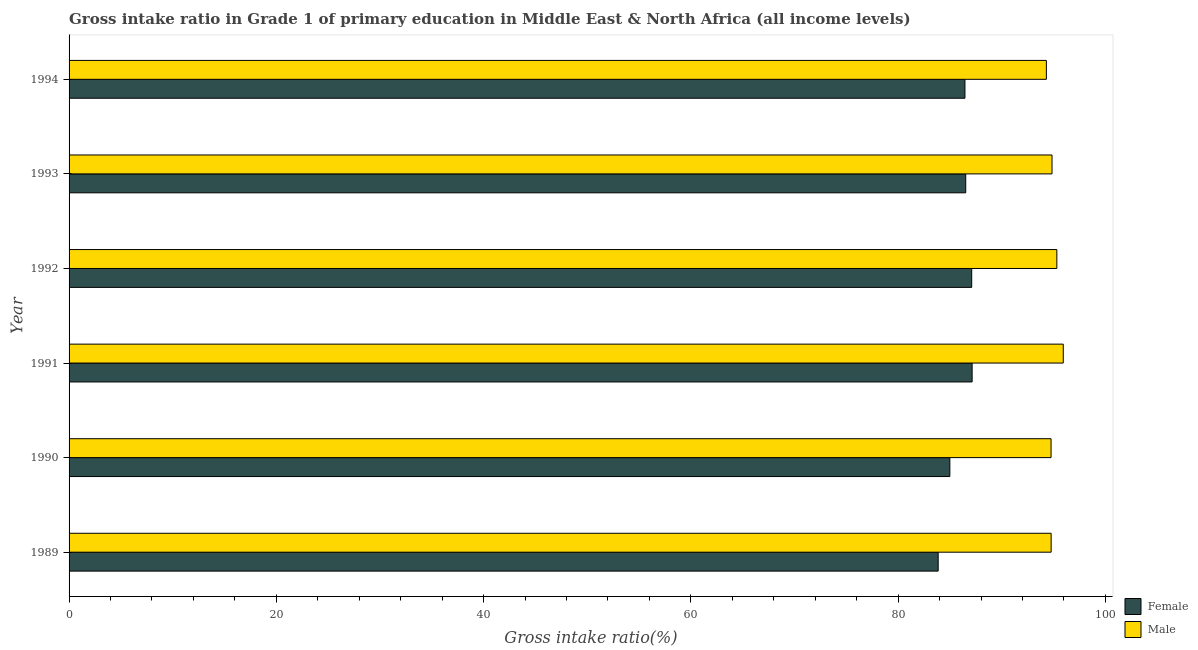How many groups of bars are there?
Provide a short and direct response. 6. In how many cases, is the number of bars for a given year not equal to the number of legend labels?
Ensure brevity in your answer.  0. What is the gross intake ratio(male) in 1990?
Give a very brief answer. 94.75. Across all years, what is the maximum gross intake ratio(male)?
Your answer should be very brief. 95.93. Across all years, what is the minimum gross intake ratio(male)?
Your answer should be compact. 94.3. In which year was the gross intake ratio(female) maximum?
Your answer should be compact. 1991. What is the total gross intake ratio(female) in the graph?
Ensure brevity in your answer.  516.04. What is the difference between the gross intake ratio(female) in 1991 and that in 1992?
Give a very brief answer. 0.04. What is the difference between the gross intake ratio(male) in 1991 and the gross intake ratio(female) in 1993?
Give a very brief answer. 9.41. What is the average gross intake ratio(male) per year?
Give a very brief answer. 94.98. In the year 1990, what is the difference between the gross intake ratio(female) and gross intake ratio(male)?
Offer a very short reply. -9.77. Is the gross intake ratio(male) in 1990 less than that in 1994?
Your answer should be compact. No. What is the difference between the highest and the second highest gross intake ratio(female)?
Give a very brief answer. 0.04. What is the difference between the highest and the lowest gross intake ratio(female)?
Offer a terse response. 3.28. Is the sum of the gross intake ratio(male) in 1989 and 1990 greater than the maximum gross intake ratio(female) across all years?
Give a very brief answer. Yes. How many bars are there?
Offer a terse response. 12. Are all the bars in the graph horizontal?
Ensure brevity in your answer.  Yes. Are the values on the major ticks of X-axis written in scientific E-notation?
Your answer should be very brief. No. Does the graph contain grids?
Your answer should be compact. No. How many legend labels are there?
Your answer should be very brief. 2. What is the title of the graph?
Provide a short and direct response. Gross intake ratio in Grade 1 of primary education in Middle East & North Africa (all income levels). Does "Non-residents" appear as one of the legend labels in the graph?
Your answer should be compact. No. What is the label or title of the X-axis?
Keep it short and to the point. Gross intake ratio(%). What is the Gross intake ratio(%) in Female in 1989?
Your answer should be compact. 83.86. What is the Gross intake ratio(%) of Male in 1989?
Your response must be concise. 94.76. What is the Gross intake ratio(%) of Female in 1990?
Keep it short and to the point. 84.99. What is the Gross intake ratio(%) of Male in 1990?
Make the answer very short. 94.75. What is the Gross intake ratio(%) in Female in 1991?
Offer a terse response. 87.14. What is the Gross intake ratio(%) in Male in 1991?
Provide a short and direct response. 95.93. What is the Gross intake ratio(%) in Female in 1992?
Offer a terse response. 87.1. What is the Gross intake ratio(%) in Male in 1992?
Make the answer very short. 95.31. What is the Gross intake ratio(%) in Female in 1993?
Provide a succinct answer. 86.52. What is the Gross intake ratio(%) in Male in 1993?
Provide a succinct answer. 94.84. What is the Gross intake ratio(%) in Female in 1994?
Provide a succinct answer. 86.44. What is the Gross intake ratio(%) in Male in 1994?
Make the answer very short. 94.3. Across all years, what is the maximum Gross intake ratio(%) of Female?
Keep it short and to the point. 87.14. Across all years, what is the maximum Gross intake ratio(%) of Male?
Provide a succinct answer. 95.93. Across all years, what is the minimum Gross intake ratio(%) of Female?
Offer a very short reply. 83.86. Across all years, what is the minimum Gross intake ratio(%) of Male?
Your response must be concise. 94.3. What is the total Gross intake ratio(%) in Female in the graph?
Keep it short and to the point. 516.04. What is the total Gross intake ratio(%) of Male in the graph?
Provide a succinct answer. 569.9. What is the difference between the Gross intake ratio(%) of Female in 1989 and that in 1990?
Provide a succinct answer. -1.13. What is the difference between the Gross intake ratio(%) in Male in 1989 and that in 1990?
Give a very brief answer. 0.01. What is the difference between the Gross intake ratio(%) of Female in 1989 and that in 1991?
Ensure brevity in your answer.  -3.28. What is the difference between the Gross intake ratio(%) of Male in 1989 and that in 1991?
Your answer should be compact. -1.17. What is the difference between the Gross intake ratio(%) in Female in 1989 and that in 1992?
Make the answer very short. -3.24. What is the difference between the Gross intake ratio(%) of Male in 1989 and that in 1992?
Your answer should be compact. -0.55. What is the difference between the Gross intake ratio(%) of Female in 1989 and that in 1993?
Ensure brevity in your answer.  -2.66. What is the difference between the Gross intake ratio(%) of Male in 1989 and that in 1993?
Your answer should be compact. -0.08. What is the difference between the Gross intake ratio(%) of Female in 1989 and that in 1994?
Provide a succinct answer. -2.58. What is the difference between the Gross intake ratio(%) in Male in 1989 and that in 1994?
Offer a very short reply. 0.46. What is the difference between the Gross intake ratio(%) of Female in 1990 and that in 1991?
Ensure brevity in your answer.  -2.15. What is the difference between the Gross intake ratio(%) of Male in 1990 and that in 1991?
Your response must be concise. -1.18. What is the difference between the Gross intake ratio(%) of Female in 1990 and that in 1992?
Provide a succinct answer. -2.11. What is the difference between the Gross intake ratio(%) of Male in 1990 and that in 1992?
Ensure brevity in your answer.  -0.56. What is the difference between the Gross intake ratio(%) of Female in 1990 and that in 1993?
Keep it short and to the point. -1.53. What is the difference between the Gross intake ratio(%) in Male in 1990 and that in 1993?
Give a very brief answer. -0.09. What is the difference between the Gross intake ratio(%) of Female in 1990 and that in 1994?
Give a very brief answer. -1.46. What is the difference between the Gross intake ratio(%) in Male in 1990 and that in 1994?
Make the answer very short. 0.45. What is the difference between the Gross intake ratio(%) of Female in 1991 and that in 1992?
Offer a terse response. 0.04. What is the difference between the Gross intake ratio(%) in Male in 1991 and that in 1992?
Provide a short and direct response. 0.62. What is the difference between the Gross intake ratio(%) of Female in 1991 and that in 1993?
Provide a short and direct response. 0.62. What is the difference between the Gross intake ratio(%) of Male in 1991 and that in 1993?
Offer a very short reply. 1.09. What is the difference between the Gross intake ratio(%) of Female in 1991 and that in 1994?
Offer a terse response. 0.69. What is the difference between the Gross intake ratio(%) of Male in 1991 and that in 1994?
Make the answer very short. 1.63. What is the difference between the Gross intake ratio(%) of Female in 1992 and that in 1993?
Your answer should be very brief. 0.58. What is the difference between the Gross intake ratio(%) in Male in 1992 and that in 1993?
Offer a very short reply. 0.47. What is the difference between the Gross intake ratio(%) in Female in 1992 and that in 1994?
Give a very brief answer. 0.65. What is the difference between the Gross intake ratio(%) of Male in 1992 and that in 1994?
Your answer should be very brief. 1.01. What is the difference between the Gross intake ratio(%) of Female in 1993 and that in 1994?
Provide a succinct answer. 0.08. What is the difference between the Gross intake ratio(%) in Male in 1993 and that in 1994?
Keep it short and to the point. 0.54. What is the difference between the Gross intake ratio(%) in Female in 1989 and the Gross intake ratio(%) in Male in 1990?
Offer a terse response. -10.89. What is the difference between the Gross intake ratio(%) in Female in 1989 and the Gross intake ratio(%) in Male in 1991?
Your answer should be compact. -12.07. What is the difference between the Gross intake ratio(%) of Female in 1989 and the Gross intake ratio(%) of Male in 1992?
Give a very brief answer. -11.45. What is the difference between the Gross intake ratio(%) in Female in 1989 and the Gross intake ratio(%) in Male in 1993?
Give a very brief answer. -10.98. What is the difference between the Gross intake ratio(%) of Female in 1989 and the Gross intake ratio(%) of Male in 1994?
Keep it short and to the point. -10.44. What is the difference between the Gross intake ratio(%) of Female in 1990 and the Gross intake ratio(%) of Male in 1991?
Offer a very short reply. -10.94. What is the difference between the Gross intake ratio(%) of Female in 1990 and the Gross intake ratio(%) of Male in 1992?
Keep it short and to the point. -10.32. What is the difference between the Gross intake ratio(%) of Female in 1990 and the Gross intake ratio(%) of Male in 1993?
Ensure brevity in your answer.  -9.86. What is the difference between the Gross intake ratio(%) of Female in 1990 and the Gross intake ratio(%) of Male in 1994?
Your response must be concise. -9.31. What is the difference between the Gross intake ratio(%) in Female in 1991 and the Gross intake ratio(%) in Male in 1992?
Your response must be concise. -8.17. What is the difference between the Gross intake ratio(%) of Female in 1991 and the Gross intake ratio(%) of Male in 1993?
Give a very brief answer. -7.71. What is the difference between the Gross intake ratio(%) of Female in 1991 and the Gross intake ratio(%) of Male in 1994?
Make the answer very short. -7.16. What is the difference between the Gross intake ratio(%) of Female in 1992 and the Gross intake ratio(%) of Male in 1993?
Provide a short and direct response. -7.75. What is the difference between the Gross intake ratio(%) of Female in 1992 and the Gross intake ratio(%) of Male in 1994?
Provide a succinct answer. -7.2. What is the difference between the Gross intake ratio(%) of Female in 1993 and the Gross intake ratio(%) of Male in 1994?
Make the answer very short. -7.78. What is the average Gross intake ratio(%) in Female per year?
Offer a very short reply. 86.01. What is the average Gross intake ratio(%) of Male per year?
Keep it short and to the point. 94.98. In the year 1989, what is the difference between the Gross intake ratio(%) of Female and Gross intake ratio(%) of Male?
Offer a terse response. -10.9. In the year 1990, what is the difference between the Gross intake ratio(%) in Female and Gross intake ratio(%) in Male?
Your answer should be very brief. -9.77. In the year 1991, what is the difference between the Gross intake ratio(%) of Female and Gross intake ratio(%) of Male?
Provide a short and direct response. -8.79. In the year 1992, what is the difference between the Gross intake ratio(%) of Female and Gross intake ratio(%) of Male?
Provide a succinct answer. -8.22. In the year 1993, what is the difference between the Gross intake ratio(%) of Female and Gross intake ratio(%) of Male?
Your answer should be compact. -8.32. In the year 1994, what is the difference between the Gross intake ratio(%) of Female and Gross intake ratio(%) of Male?
Give a very brief answer. -7.86. What is the ratio of the Gross intake ratio(%) of Female in 1989 to that in 1990?
Provide a short and direct response. 0.99. What is the ratio of the Gross intake ratio(%) in Male in 1989 to that in 1990?
Your answer should be very brief. 1. What is the ratio of the Gross intake ratio(%) of Female in 1989 to that in 1991?
Give a very brief answer. 0.96. What is the ratio of the Gross intake ratio(%) of Male in 1989 to that in 1991?
Your response must be concise. 0.99. What is the ratio of the Gross intake ratio(%) of Female in 1989 to that in 1992?
Provide a short and direct response. 0.96. What is the ratio of the Gross intake ratio(%) of Male in 1989 to that in 1992?
Offer a very short reply. 0.99. What is the ratio of the Gross intake ratio(%) in Female in 1989 to that in 1993?
Offer a terse response. 0.97. What is the ratio of the Gross intake ratio(%) in Female in 1989 to that in 1994?
Give a very brief answer. 0.97. What is the ratio of the Gross intake ratio(%) in Male in 1989 to that in 1994?
Provide a succinct answer. 1. What is the ratio of the Gross intake ratio(%) of Female in 1990 to that in 1991?
Make the answer very short. 0.98. What is the ratio of the Gross intake ratio(%) in Female in 1990 to that in 1992?
Your response must be concise. 0.98. What is the ratio of the Gross intake ratio(%) of Female in 1990 to that in 1993?
Provide a succinct answer. 0.98. What is the ratio of the Gross intake ratio(%) in Male in 1990 to that in 1993?
Make the answer very short. 1. What is the ratio of the Gross intake ratio(%) of Female in 1990 to that in 1994?
Ensure brevity in your answer.  0.98. What is the ratio of the Gross intake ratio(%) in Male in 1990 to that in 1994?
Keep it short and to the point. 1. What is the ratio of the Gross intake ratio(%) in Female in 1991 to that in 1992?
Provide a succinct answer. 1. What is the ratio of the Gross intake ratio(%) in Male in 1991 to that in 1992?
Offer a terse response. 1.01. What is the ratio of the Gross intake ratio(%) of Female in 1991 to that in 1993?
Your response must be concise. 1.01. What is the ratio of the Gross intake ratio(%) of Male in 1991 to that in 1993?
Your answer should be very brief. 1.01. What is the ratio of the Gross intake ratio(%) in Male in 1991 to that in 1994?
Offer a very short reply. 1.02. What is the ratio of the Gross intake ratio(%) of Female in 1992 to that in 1994?
Your response must be concise. 1.01. What is the ratio of the Gross intake ratio(%) in Male in 1992 to that in 1994?
Give a very brief answer. 1.01. What is the ratio of the Gross intake ratio(%) in Female in 1993 to that in 1994?
Keep it short and to the point. 1. What is the ratio of the Gross intake ratio(%) of Male in 1993 to that in 1994?
Offer a terse response. 1.01. What is the difference between the highest and the second highest Gross intake ratio(%) in Female?
Provide a short and direct response. 0.04. What is the difference between the highest and the second highest Gross intake ratio(%) in Male?
Your response must be concise. 0.62. What is the difference between the highest and the lowest Gross intake ratio(%) of Female?
Provide a short and direct response. 3.28. What is the difference between the highest and the lowest Gross intake ratio(%) in Male?
Make the answer very short. 1.63. 